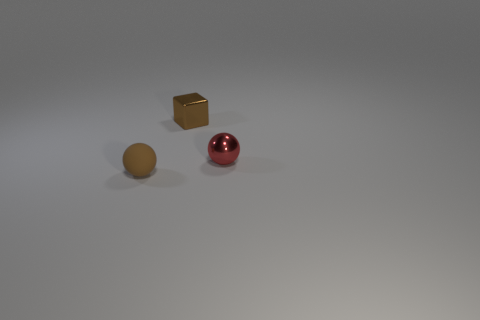Is the tiny rubber thing the same shape as the small red object?
Your response must be concise. Yes. Is there any other thing of the same color as the tiny matte object?
Ensure brevity in your answer.  Yes. How many things are either tiny brown objects or metal objects in front of the tiny brown block?
Your response must be concise. 3. Is the number of small matte objects left of the metallic ball greater than the number of tiny cyan shiny cubes?
Give a very brief answer. Yes. Are there the same number of matte balls on the left side of the small brown rubber sphere and small red spheres that are behind the brown metal block?
Offer a very short reply. Yes. Are there any small things that are left of the ball in front of the tiny red thing?
Make the answer very short. No. What shape is the small matte object?
Offer a terse response. Sphere. The shiny cube that is the same color as the matte object is what size?
Provide a short and direct response. Small. There is a sphere to the right of the tiny metal block behind the brown matte thing; how big is it?
Ensure brevity in your answer.  Small. There is a sphere that is behind the brown sphere; how big is it?
Make the answer very short. Small. 